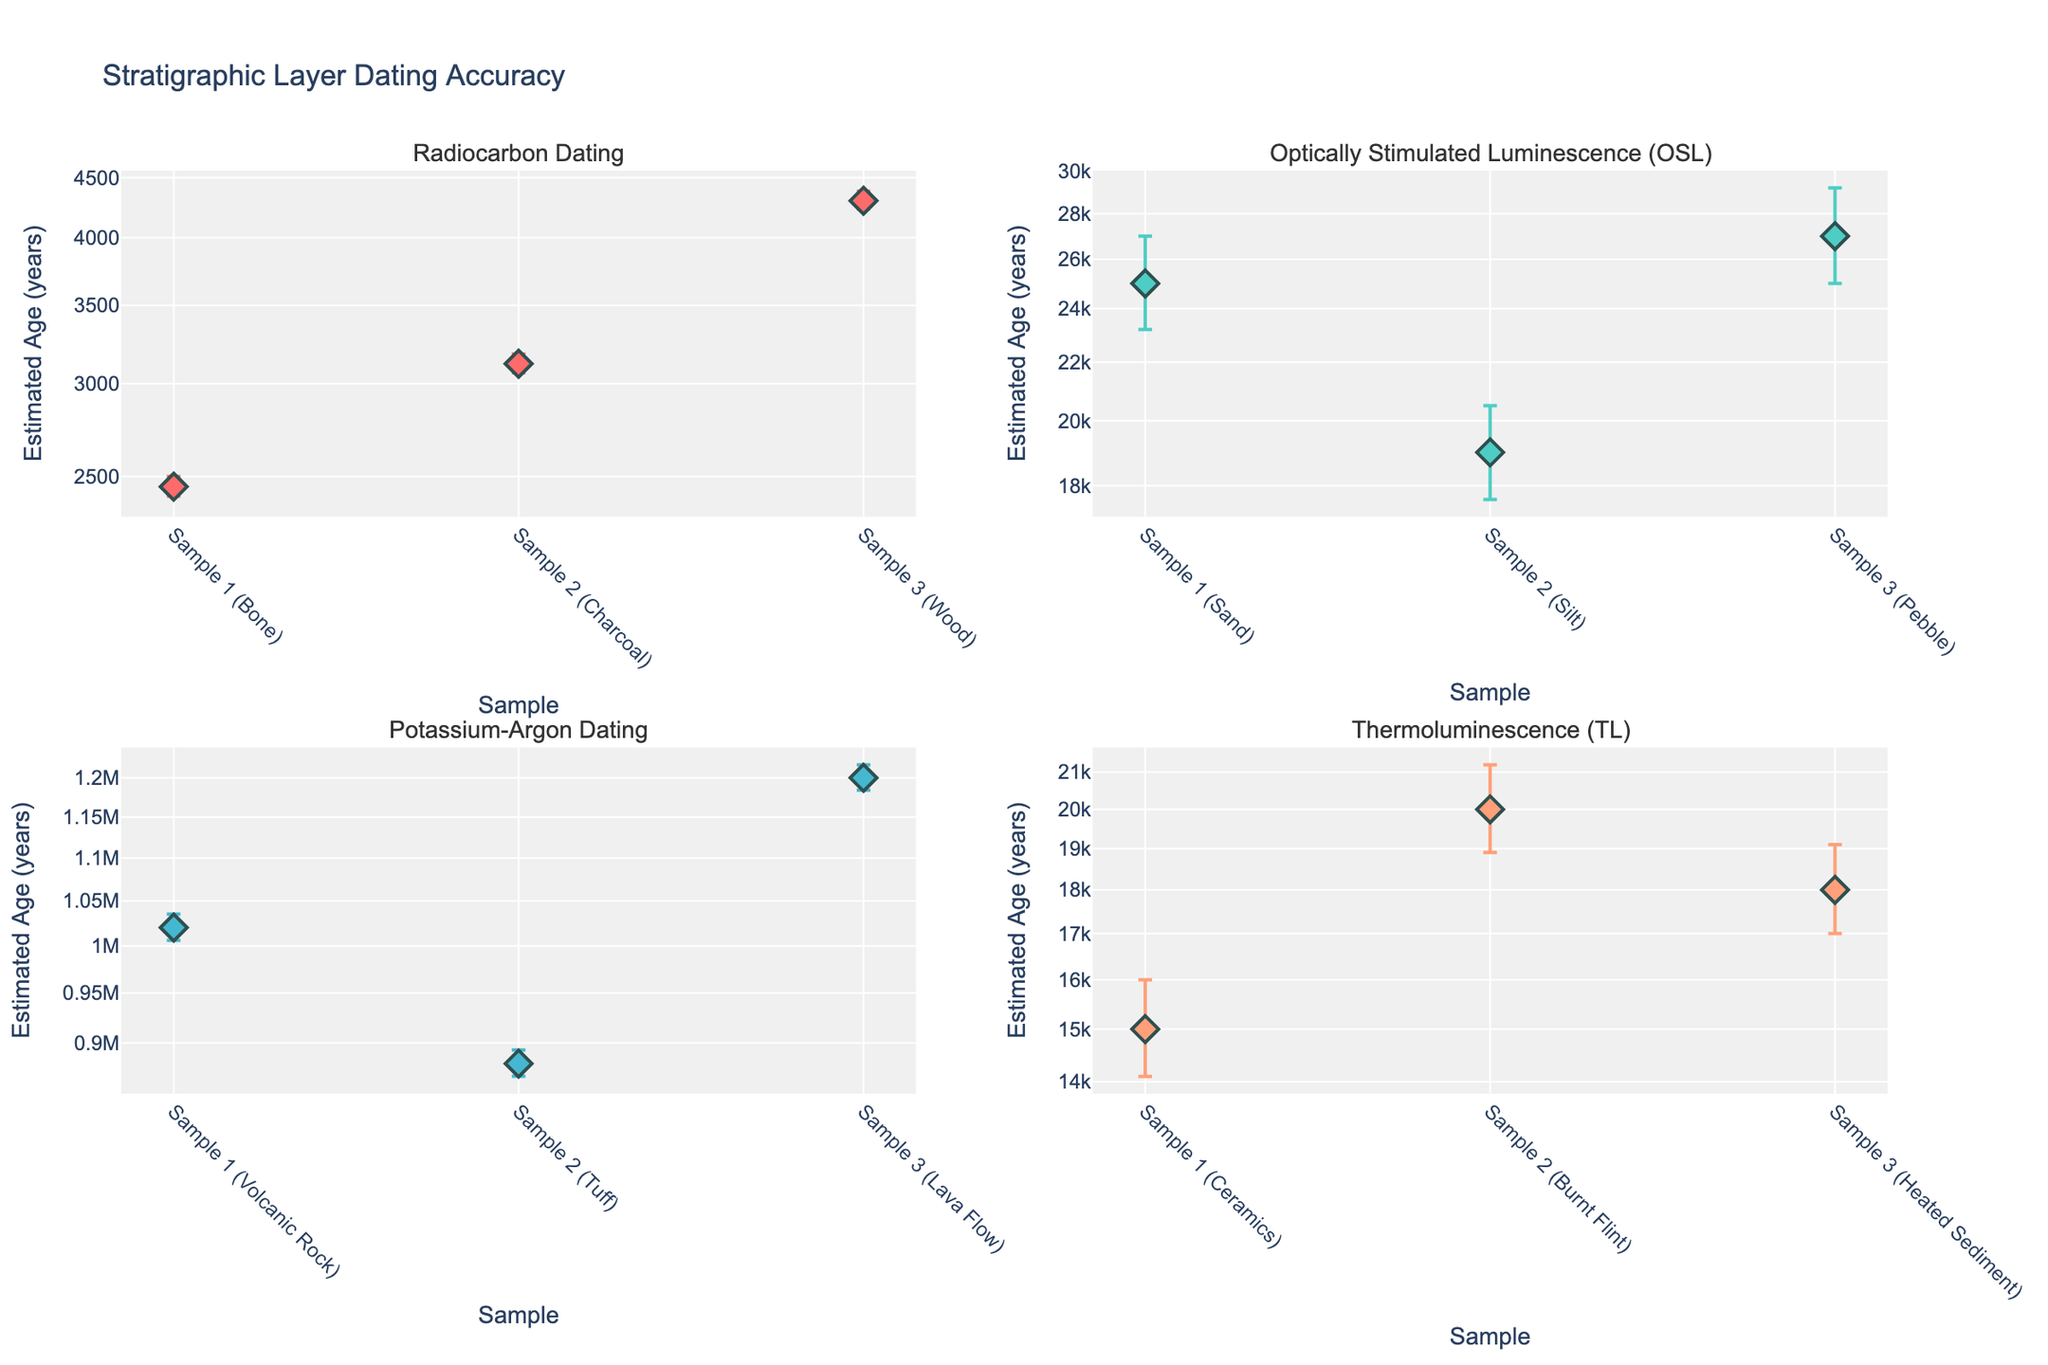what is the title of the figure? The title of the figure is usually displayed at the top of the plot. In this case, it is mentioned in the code that the title is set to "Stratigraphic Layer Dating Accuracy".
Answer: Stratigraphic Layer Dating Accuracy How many subplots are in the figure? By observing the figure layout, we see that there are 2 rows and 2 columns of subplots. This makes a total of 4 subplots. This matches the number of unique techniques mentioned in the data.
Answer: 4 What is the estimated age and error margin ranges for Sample 1 using Radiocarbon Dating? From the Radiocarbon Dating subplot, observe Sample 1 (Bone). The x-axis lists the sample, and the y-axis shows the estimated age with error bars. The age is given as 2450 years with error margins of +50 and -45 years.
Answer: 2450 years (+50, -45) Which dating technique has the largest error margins? By comparing the size of the error bars across all subplots, we see that the Optically Stimulated Luminescence (OSL) technique has the largest error margins.
Answer: Optically Stimulated Luminescence (OSL) What is the difference in estimated age between Sample 1 and Sample 2 in Thermoluminescence (TL) dating? Look at the Thermoluminescence (TL) subplot and compare the ages of Sample 1 (Ceramics) and Sample 2 (Burnt Flint). Sample 1 is 15000 years and Sample 2 is 20000 years. The difference is 20000 - 15000 = 5000 years.
Answer: 5000 years Which sample and technique combination has the oldest estimated age? By looking at the y-axis values in all subplots, we see that Sample 3 (Lava Flow) in Potassium-Argon Dating has the oldest estimated age of 1200000 years.
Answer: Sample 3 (Lava Flow) in Potassium-Argon Dating How does the error margin of Sample 2 in OSL compare to the error margin of Sample 3 in TL? Observe the error margins for Sample 2 (Silt) in OSL and Sample 3 (Heated Sediment) in TL. For OSL, the error is +1500 and -1400 years. For TL, it’s +1100 and -1000 years. The error margins in OSL are larger.
Answer: OSL has larger error margins Which samples in Radiocarbon Dating have symmetrical error margins? In Radiocarbon Dating, we check the error margins for each sample. Symmetrical margins mean the plus and minus values are equal. Here, none of the samples have symmetrical error margins as all had slight differences.
Answer: None On a logarithmic scale, how does the positioning of the samples within each technique help in understanding dating accuracy? In a logarithmic scale, data spanning several orders of magnitude can be visualized proportionally. This helps in comparing dating accuracy across vastly different time scales and identifying which techniques provide more precise dating for specific periods.
Answer: Facilitates comparison of dating accuracy across time scales 